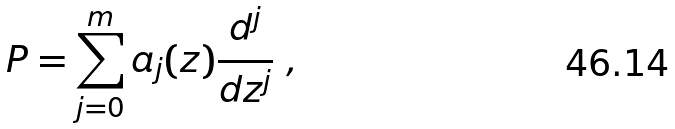<formula> <loc_0><loc_0><loc_500><loc_500>P = \sum _ { j = 0 } ^ { m } a _ { j } ( z ) \frac { d ^ { j } } { d z ^ { j } } \ ,</formula> 